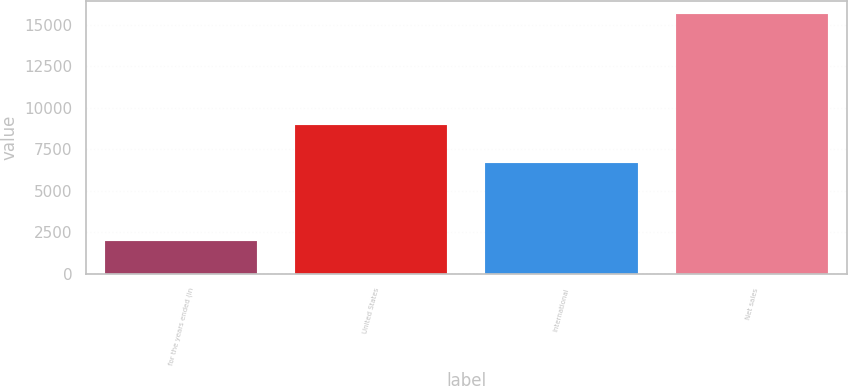Convert chart. <chart><loc_0><loc_0><loc_500><loc_500><bar_chart><fcel>for the years ended (in<fcel>United States<fcel>International<fcel>Net sales<nl><fcel>2010<fcel>8971<fcel>6667<fcel>15638<nl></chart> 